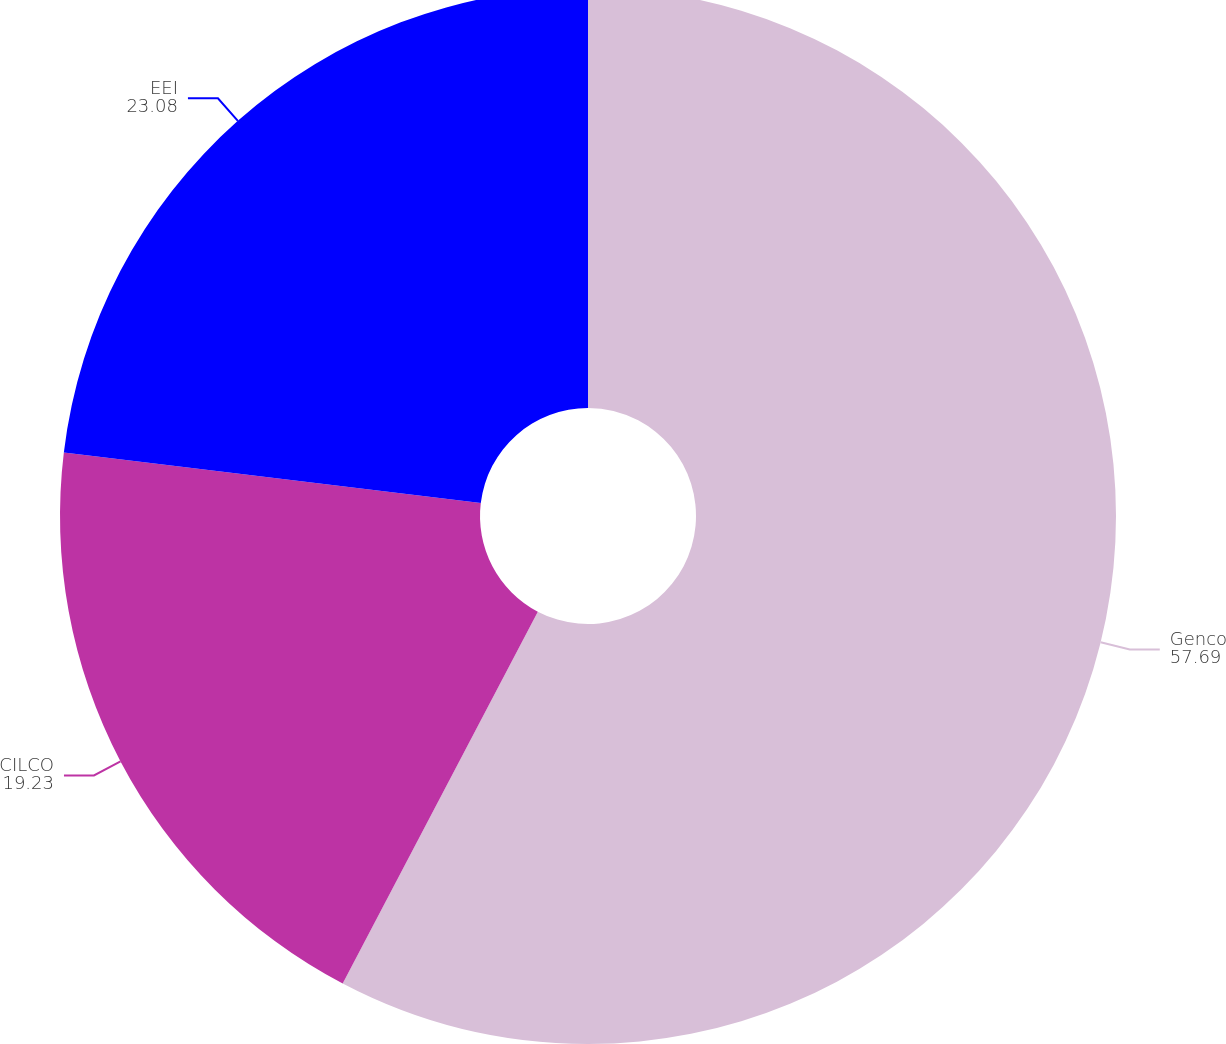<chart> <loc_0><loc_0><loc_500><loc_500><pie_chart><fcel>Genco<fcel>CILCO<fcel>EEI<nl><fcel>57.69%<fcel>19.23%<fcel>23.08%<nl></chart> 